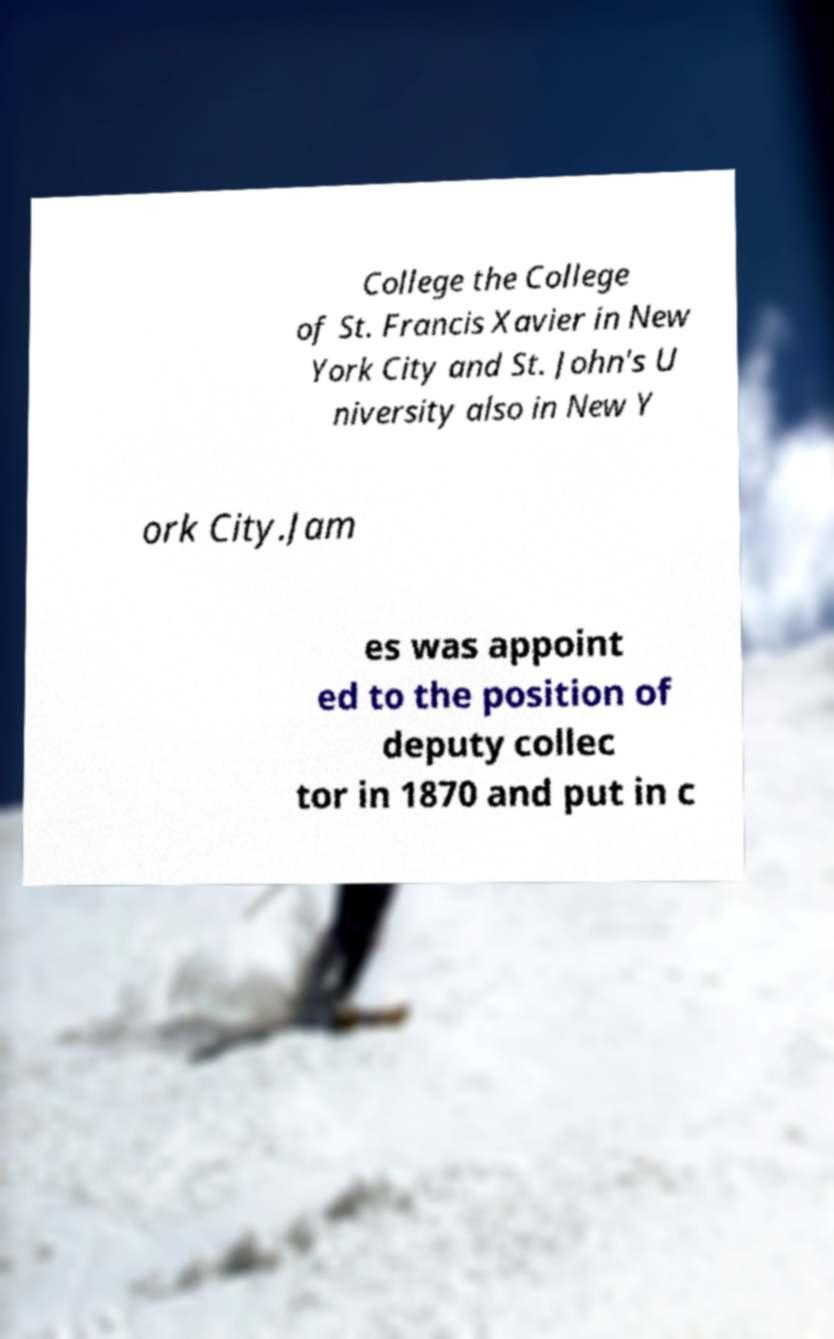What messages or text are displayed in this image? I need them in a readable, typed format. College the College of St. Francis Xavier in New York City and St. John's U niversity also in New Y ork City.Jam es was appoint ed to the position of deputy collec tor in 1870 and put in c 